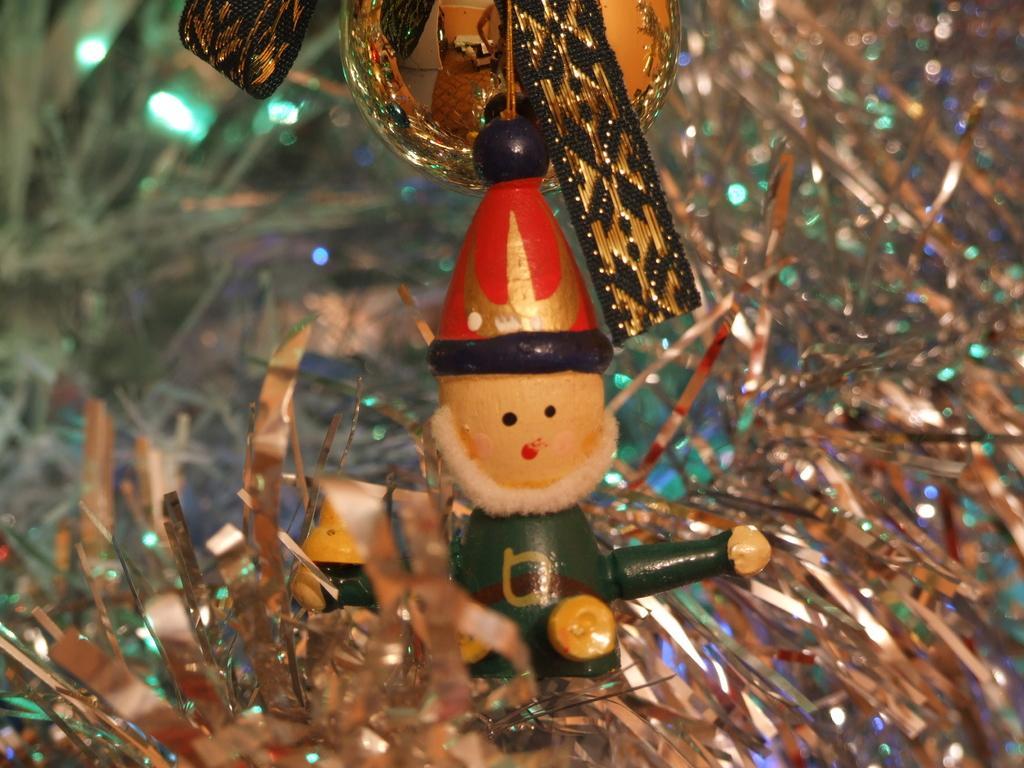How would you summarize this image in a sentence or two? It is a decoration and in between the declaration there is a doll of Santa Claus. 